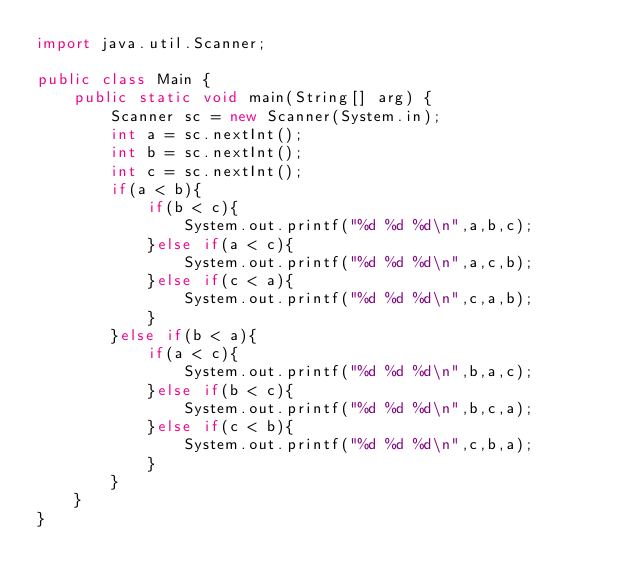<code> <loc_0><loc_0><loc_500><loc_500><_Java_>import java.util.Scanner;

public class Main {
	public static void main(String[] arg) {
		Scanner sc = new Scanner(System.in);
		int a = sc.nextInt();
		int b = sc.nextInt();
		int c = sc.nextInt();
		if(a < b){
			if(b < c){
				System.out.printf("%d %d %d\n",a,b,c);
			}else if(a < c){
				System.out.printf("%d %d %d\n",a,c,b);
			}else if(c < a){
				System.out.printf("%d %d %d\n",c,a,b);
			}
		}else if(b < a){
			if(a < c){
				System.out.printf("%d %d %d\n",b,a,c);
			}else if(b < c){
				System.out.printf("%d %d %d\n",b,c,a);
			}else if(c < b){
				System.out.printf("%d %d %d\n",c,b,a);
			}
		}
	}
}</code> 